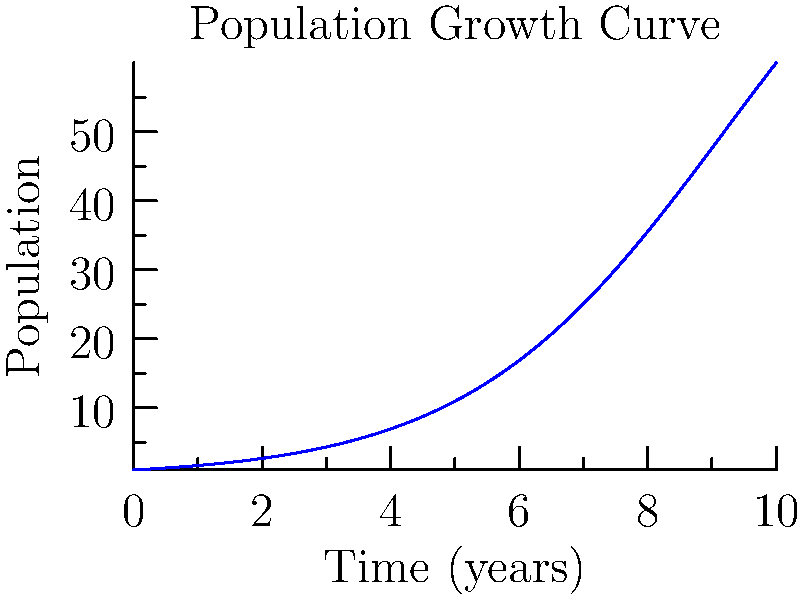A study group you're mentoring is researching population growth in a disadvantaged urban area. The graph shows a logistic growth model for this population over time. At what point in time (in years) is the rate of population growth the highest? Explain your reasoning and how this information could be useful for community planning. To find the point of highest growth rate in a logistic growth curve, we need to follow these steps:

1) The logistic growth curve is symmetric, and the point of highest growth rate occurs at the inflection point of the curve.

2) The inflection point is located at the middle of the sigmoid curve, halfway between the lower and upper asymptotes.

3) From the graph, we can see that:
   - The lower asymptote is at 0
   - The upper asymptote is at 100

4) The inflection point will occur when the population reaches half of the upper asymptote: 100/2 = 50

5) Looking at the y-axis, we can estimate that the population reaches 50 at approximately 5 years.

This information is crucial for community planning as it indicates when resources will need to be expanded most rapidly to accommodate the growing population. It's the point where the demand for services like education, healthcare, and housing will be increasing at the fastest rate.
Answer: 5 years 